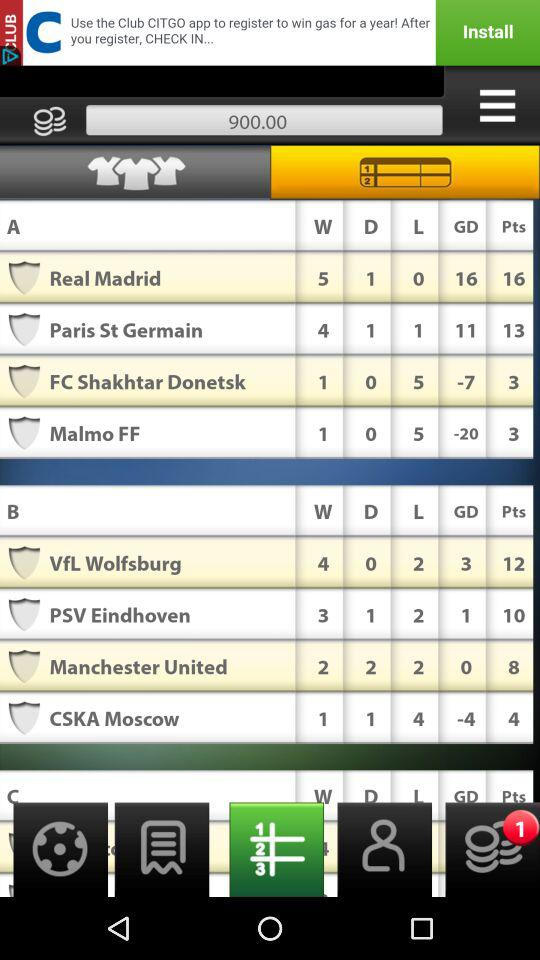How many total points does "Malmo FF" contain? "Malmo FF" contains three points. 